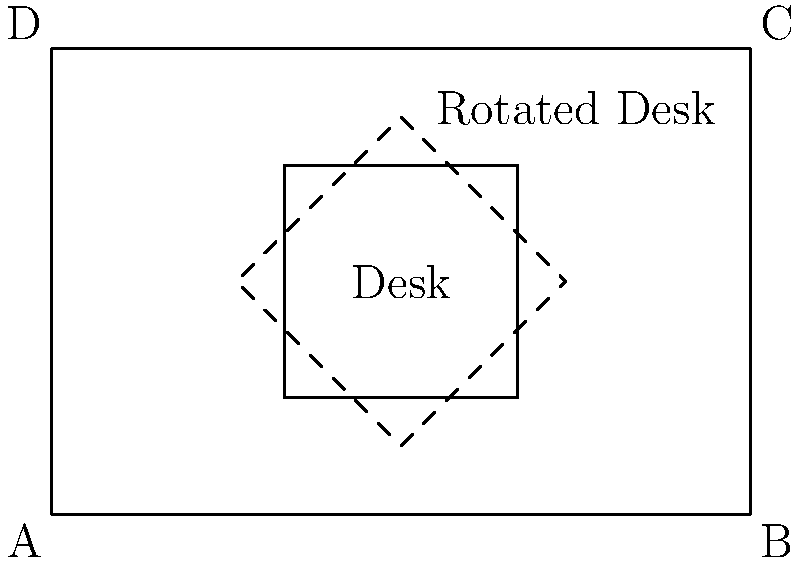In a home office, a rectangular desk (2 units by 4 units) is centered in a 6x4 unit room. To optimize space utilization, the desk needs to be rotated 45° clockwise around its center. What is the new x-coordinate of the top-right corner of the rotated desk? To solve this problem, we'll follow these steps:

1) First, identify the initial coordinates of the desk's top-right corner:
   The desk is 2x4 units, centered in a 6x4 room.
   Initial top-right corner: (4, 3)

2) Identify the center of rotation:
   The desk is centered in the room, so the center is at (3, 2)

3) Use the rotation formula to find the new coordinates:
   $x' = x_c + (x - x_c) \cos \theta - (y - y_c) \sin \theta$
   $y' = y_c + (x - x_c) \sin \theta + (y - y_c) \cos \theta$

   Where $(x_c, y_c)$ is the center of rotation, $(x, y)$ is the initial point, and $\theta$ is the angle of rotation.

4) Calculate:
   $x' = 3 + (4 - 3) \cos 45° - (3 - 2) \sin 45°$
   $x' = 3 + 1 \cdot \frac{\sqrt{2}}{2} - 1 \cdot \frac{\sqrt{2}}{2}$
   $x' = 3 + \frac{\sqrt{2}}{2} - \frac{\sqrt{2}}{2} = 3$

5) Therefore, the new x-coordinate of the top-right corner is 3.
Answer: 3 